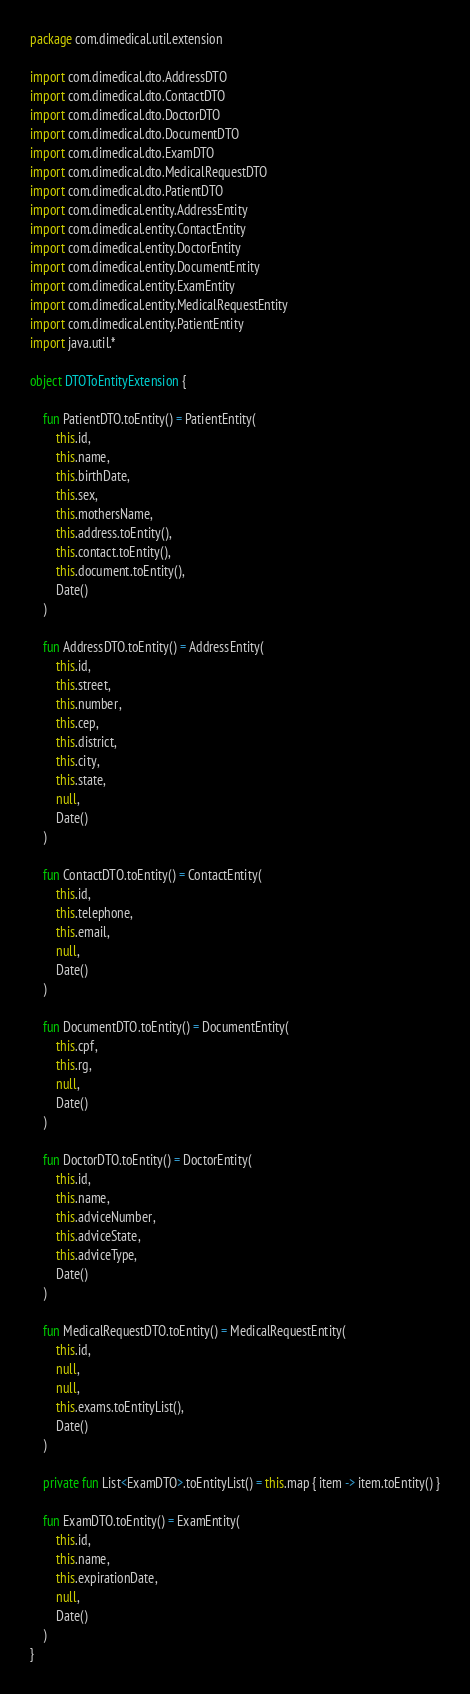Convert code to text. <code><loc_0><loc_0><loc_500><loc_500><_Kotlin_>package com.dimedical.util.extension

import com.dimedical.dto.AddressDTO
import com.dimedical.dto.ContactDTO
import com.dimedical.dto.DoctorDTO
import com.dimedical.dto.DocumentDTO
import com.dimedical.dto.ExamDTO
import com.dimedical.dto.MedicalRequestDTO
import com.dimedical.dto.PatientDTO
import com.dimedical.entity.AddressEntity
import com.dimedical.entity.ContactEntity
import com.dimedical.entity.DoctorEntity
import com.dimedical.entity.DocumentEntity
import com.dimedical.entity.ExamEntity
import com.dimedical.entity.MedicalRequestEntity
import com.dimedical.entity.PatientEntity
import java.util.*

object DTOToEntityExtension {

    fun PatientDTO.toEntity() = PatientEntity(
        this.id,
        this.name,
        this.birthDate,
        this.sex,
        this.mothersName,
        this.address.toEntity(),
        this.contact.toEntity(),
        this.document.toEntity(),
        Date()
    )

    fun AddressDTO.toEntity() = AddressEntity(
        this.id,
        this.street,
        this.number,
        this.cep,
        this.district,
        this.city,
        this.state,
        null,
        Date()
    )

    fun ContactDTO.toEntity() = ContactEntity(
        this.id,
        this.telephone,
        this.email,
        null,
        Date()
    )

    fun DocumentDTO.toEntity() = DocumentEntity(
        this.cpf,
        this.rg,
        null,
        Date()
    )

    fun DoctorDTO.toEntity() = DoctorEntity(
        this.id,
        this.name,
        this.adviceNumber,
        this.adviceState,
        this.adviceType,
        Date()
    )

    fun MedicalRequestDTO.toEntity() = MedicalRequestEntity(
        this.id,
        null,
        null,
        this.exams.toEntityList(),
        Date()
    )

    private fun List<ExamDTO>.toEntityList() = this.map { item -> item.toEntity() }

    fun ExamDTO.toEntity() = ExamEntity(
        this.id,
        this.name,
        this.expirationDate,
        null,
        Date()
    )
}
</code> 